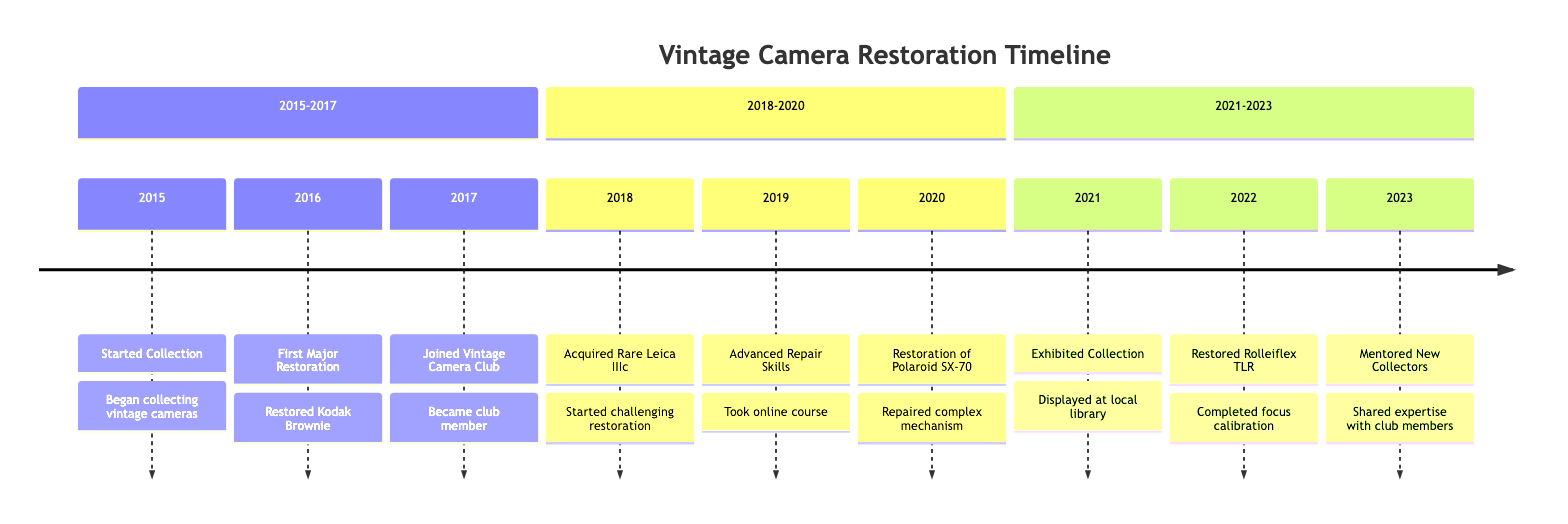What year did the collecting of vintage cameras begin? The timeline indicates that collecting of vintage cameras started in 2015.
Answer: 2015 What was the first major restoration project? According to the timeline, the first major restoration was on the Kodak Brownie camera in 2016.
Answer: Kodak Brownie How many major restoration projects are listed between 2015 and 2020? The timeline shows three major restoration projects completed from 2015 to 2020, those are: the Kodak Brownie in 2016, the Leica IIIc acquisition in 2018, and the Polaroid SX-70 restoration in 2020.
Answer: 3 What special item was acquired in 2018? The timeline specifies that a rare Leica IIIc was acquired in 2018.
Answer: Leica IIIc Which event followed the acquisition of the rare Leica IIIc? After acquiring the Leica IIIc in 2018, the next event listed is taking the online course on camera mechanics in 2019.
Answer: Advanced Repair Skills In what year did mentorship of new collectors begin? The timeline states that mentoring of new collectors started in 2023.
Answer: 2023 What involved extensive work on an electrical component? The restoration of the Polaroid SX-70 in 2020 required extensive work on its electrical components.
Answer: Polaroid SX-70 Which camera was restored with focus calibration? The Rolleiflex Twin-Lens Reflex camera was restored in 2022, and focus calibration was part of that process.
Answer: Rolleiflex TLR How many years apart were the first major restoration and the acquisition of the Leica IIIc? The first major restoration took place in 2016 and the acquisition of the Leica IIIc occurred in 2018, which is two years apart.
Answer: 2 years 